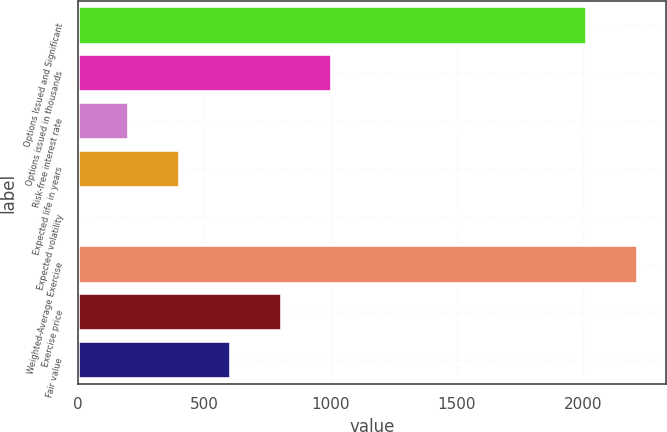<chart> <loc_0><loc_0><loc_500><loc_500><bar_chart><fcel>Options Issued and Significant<fcel>Options issued in thousands<fcel>Risk-free interest rate<fcel>Expected life in years<fcel>Expected volatility<fcel>Weighted-Average Exercise<fcel>Exercise price<fcel>Fair value<nl><fcel>2015<fcel>1007.61<fcel>201.73<fcel>403.2<fcel>0.26<fcel>2216.47<fcel>806.14<fcel>604.67<nl></chart> 